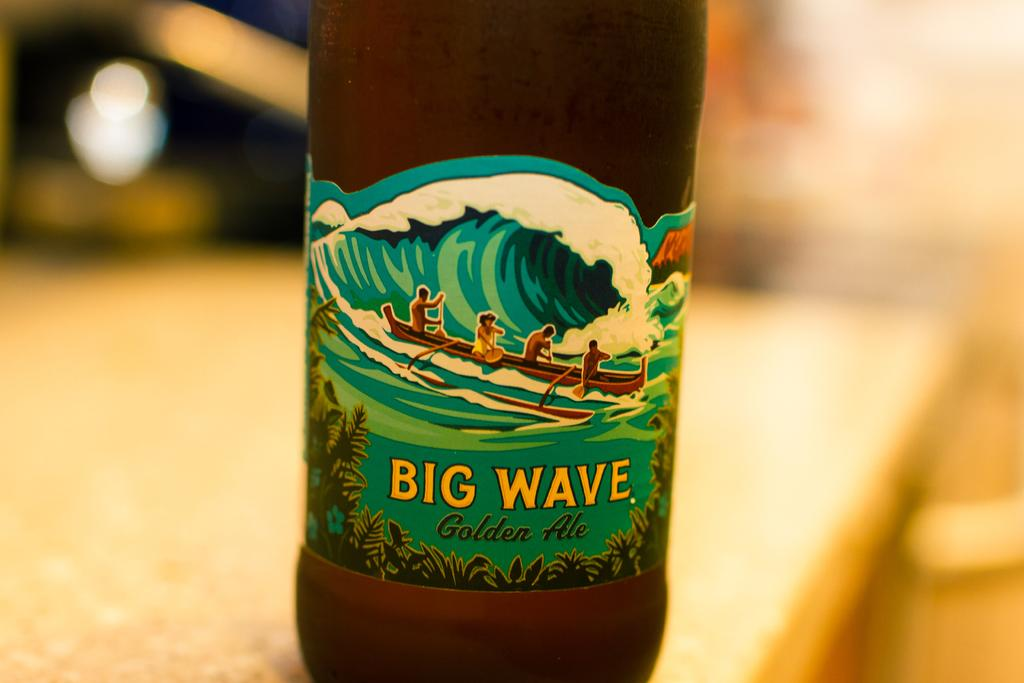<image>
Give a short and clear explanation of the subsequent image. A bottle of Big Wave golden ale contains a drawing of an outrigger canoe. 